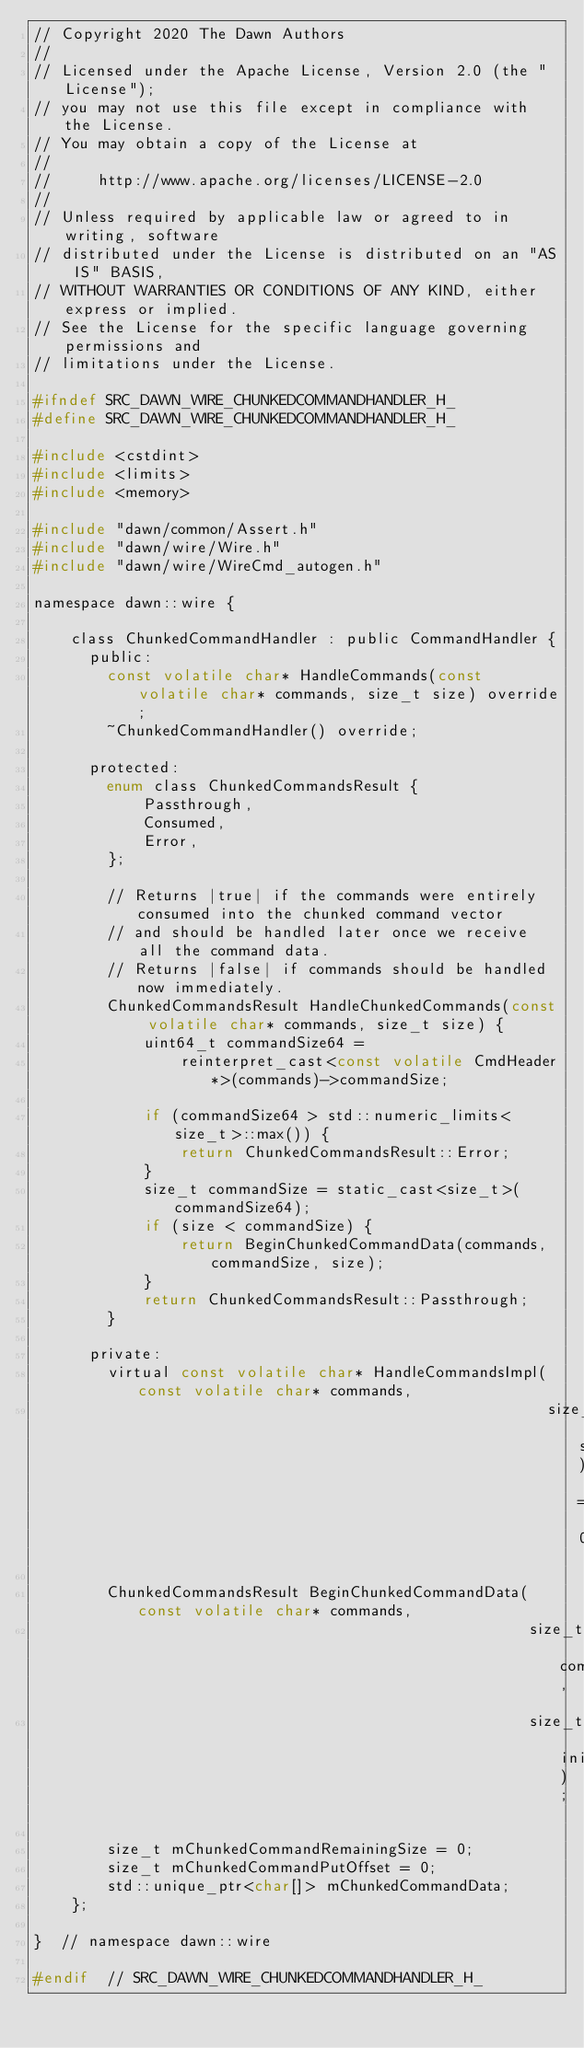Convert code to text. <code><loc_0><loc_0><loc_500><loc_500><_C_>// Copyright 2020 The Dawn Authors
//
// Licensed under the Apache License, Version 2.0 (the "License");
// you may not use this file except in compliance with the License.
// You may obtain a copy of the License at
//
//     http://www.apache.org/licenses/LICENSE-2.0
//
// Unless required by applicable law or agreed to in writing, software
// distributed under the License is distributed on an "AS IS" BASIS,
// WITHOUT WARRANTIES OR CONDITIONS OF ANY KIND, either express or implied.
// See the License for the specific language governing permissions and
// limitations under the License.

#ifndef SRC_DAWN_WIRE_CHUNKEDCOMMANDHANDLER_H_
#define SRC_DAWN_WIRE_CHUNKEDCOMMANDHANDLER_H_

#include <cstdint>
#include <limits>
#include <memory>

#include "dawn/common/Assert.h"
#include "dawn/wire/Wire.h"
#include "dawn/wire/WireCmd_autogen.h"

namespace dawn::wire {

    class ChunkedCommandHandler : public CommandHandler {
      public:
        const volatile char* HandleCommands(const volatile char* commands, size_t size) override;
        ~ChunkedCommandHandler() override;

      protected:
        enum class ChunkedCommandsResult {
            Passthrough,
            Consumed,
            Error,
        };

        // Returns |true| if the commands were entirely consumed into the chunked command vector
        // and should be handled later once we receive all the command data.
        // Returns |false| if commands should be handled now immediately.
        ChunkedCommandsResult HandleChunkedCommands(const volatile char* commands, size_t size) {
            uint64_t commandSize64 =
                reinterpret_cast<const volatile CmdHeader*>(commands)->commandSize;

            if (commandSize64 > std::numeric_limits<size_t>::max()) {
                return ChunkedCommandsResult::Error;
            }
            size_t commandSize = static_cast<size_t>(commandSize64);
            if (size < commandSize) {
                return BeginChunkedCommandData(commands, commandSize, size);
            }
            return ChunkedCommandsResult::Passthrough;
        }

      private:
        virtual const volatile char* HandleCommandsImpl(const volatile char* commands,
                                                        size_t size) = 0;

        ChunkedCommandsResult BeginChunkedCommandData(const volatile char* commands,
                                                      size_t commandSize,
                                                      size_t initialSize);

        size_t mChunkedCommandRemainingSize = 0;
        size_t mChunkedCommandPutOffset = 0;
        std::unique_ptr<char[]> mChunkedCommandData;
    };

}  // namespace dawn::wire

#endif  // SRC_DAWN_WIRE_CHUNKEDCOMMANDHANDLER_H_
</code> 